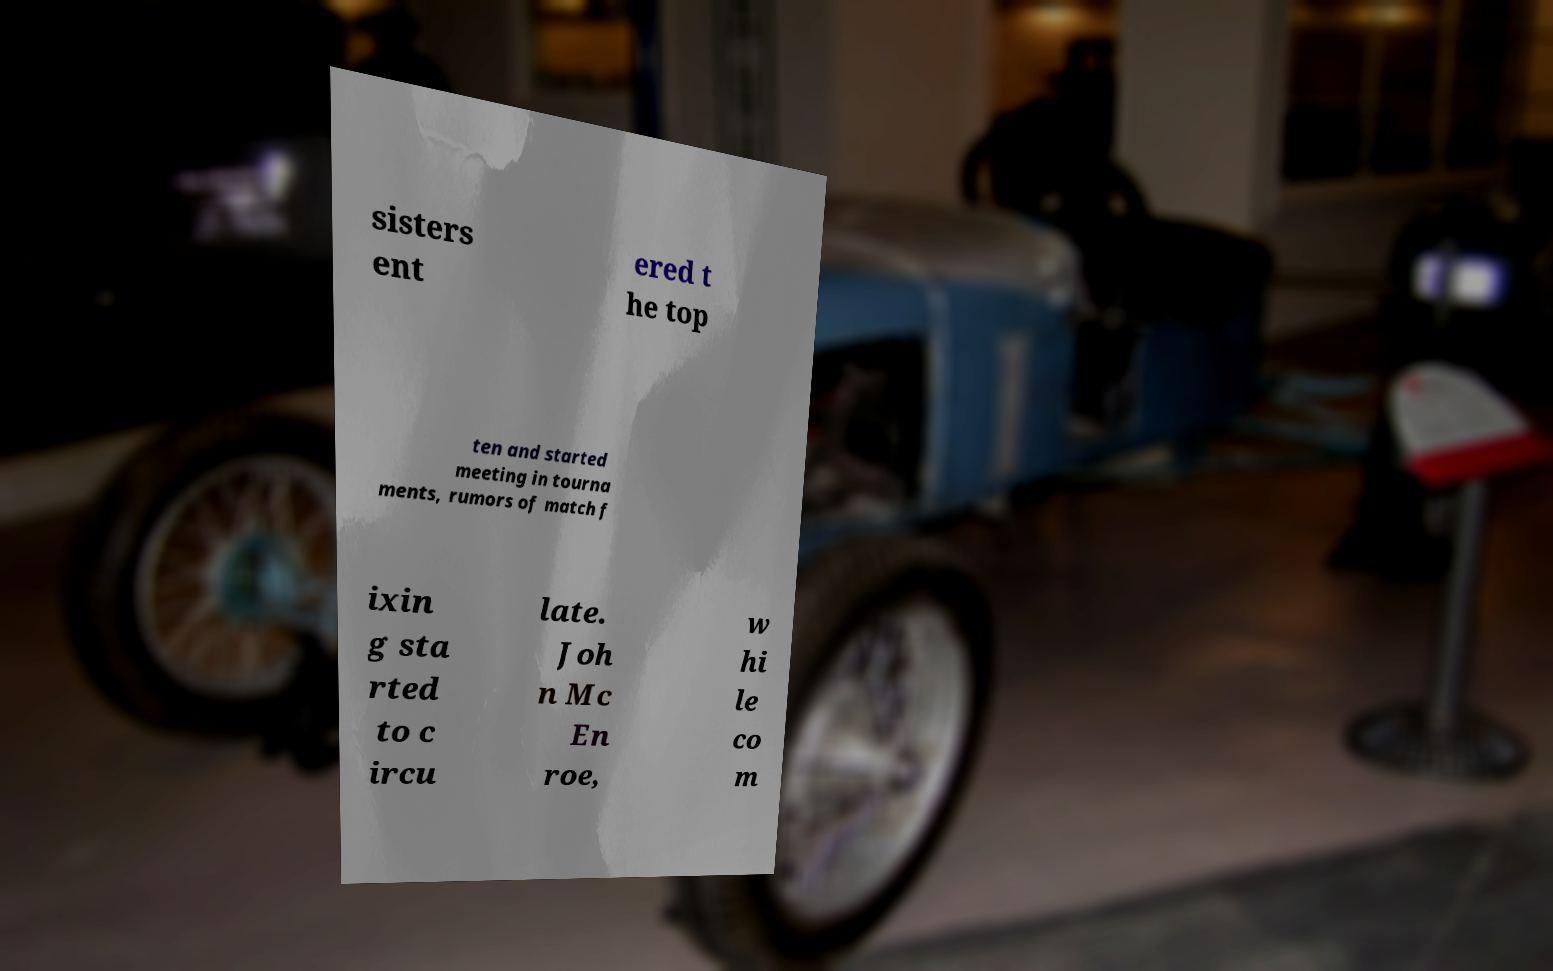Can you read and provide the text displayed in the image?This photo seems to have some interesting text. Can you extract and type it out for me? sisters ent ered t he top ten and started meeting in tourna ments, rumors of match f ixin g sta rted to c ircu late. Joh n Mc En roe, w hi le co m 